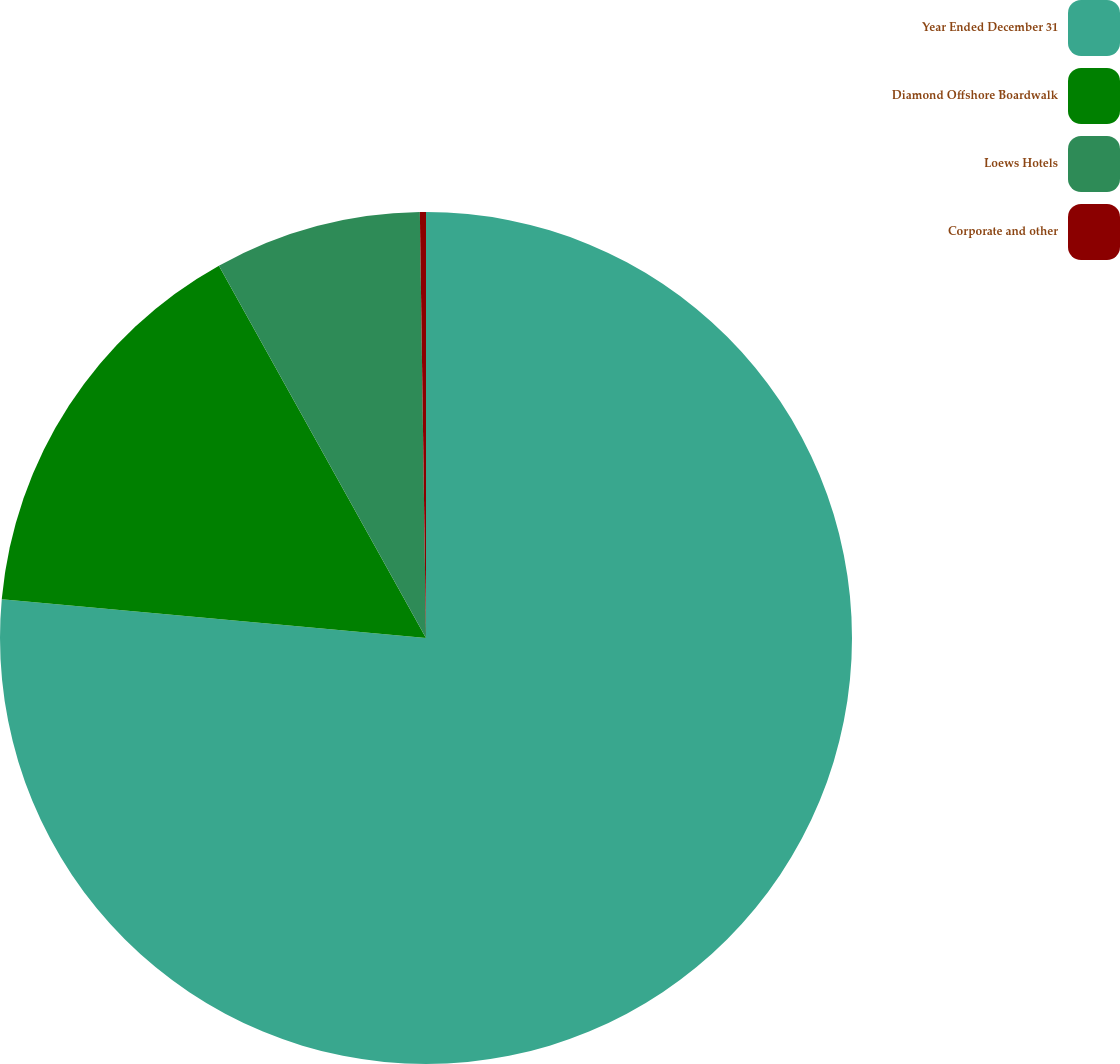Convert chart to OTSL. <chart><loc_0><loc_0><loc_500><loc_500><pie_chart><fcel>Year Ended December 31<fcel>Diamond Offshore Boardwalk<fcel>Loews Hotels<fcel>Corporate and other<nl><fcel>76.45%<fcel>15.47%<fcel>7.85%<fcel>0.23%<nl></chart> 